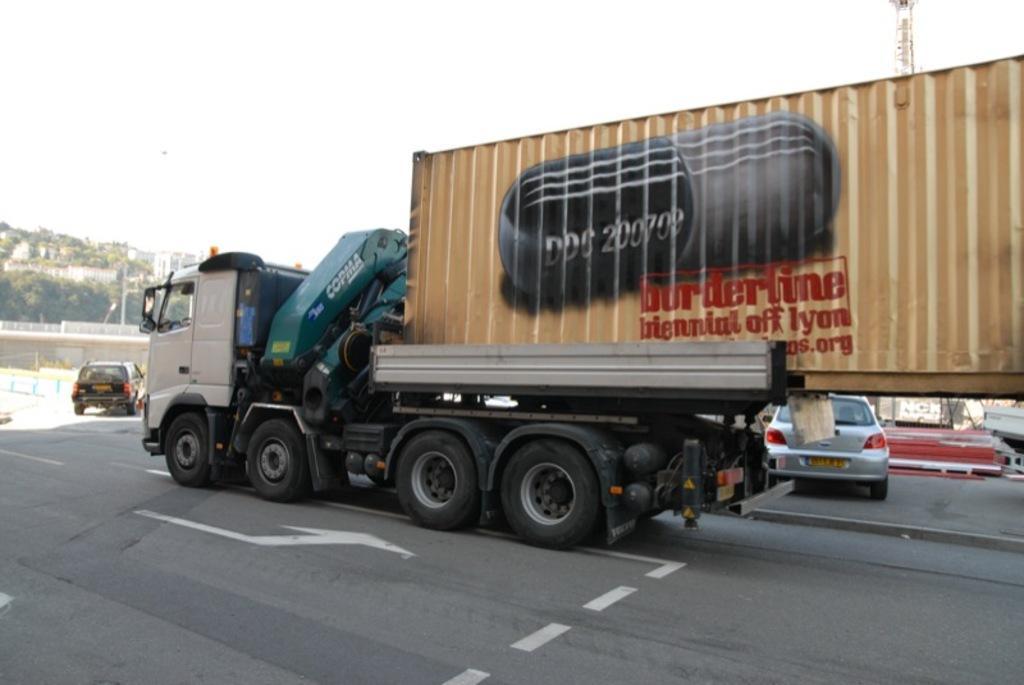Could you give a brief overview of what you see in this image? In this picture we can see vehicles on the road and in the background we can see trees, walls and some objects and the sky. 